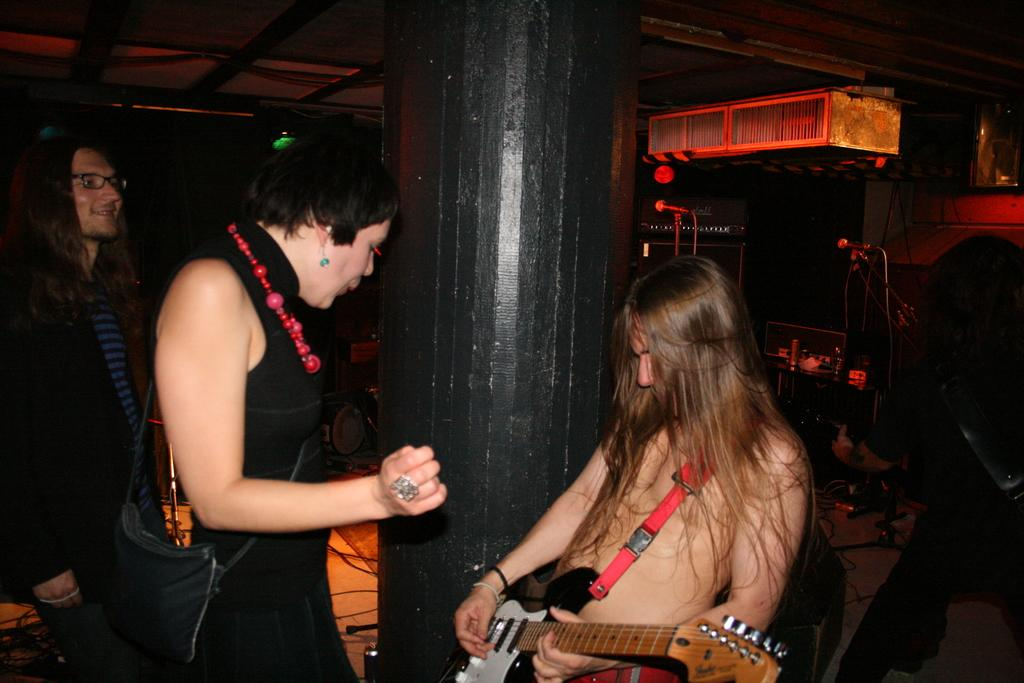How many people are in the image? There are three persons in the image. What is one person doing in the image? One person is playing a guitar. What structure can be seen in the image? There is a pillar in the image. What type of markers are present in the image? There are distance markers (miles) in the image. What else can be seen in the image besides the people and pillar? There are musical instruments in the image. What type of bun is being used as a prop in the image? There is no bun present in the image. Who is the actor in the image? The image does not depict a performance or any actors; it shows three people and musical instruments. 